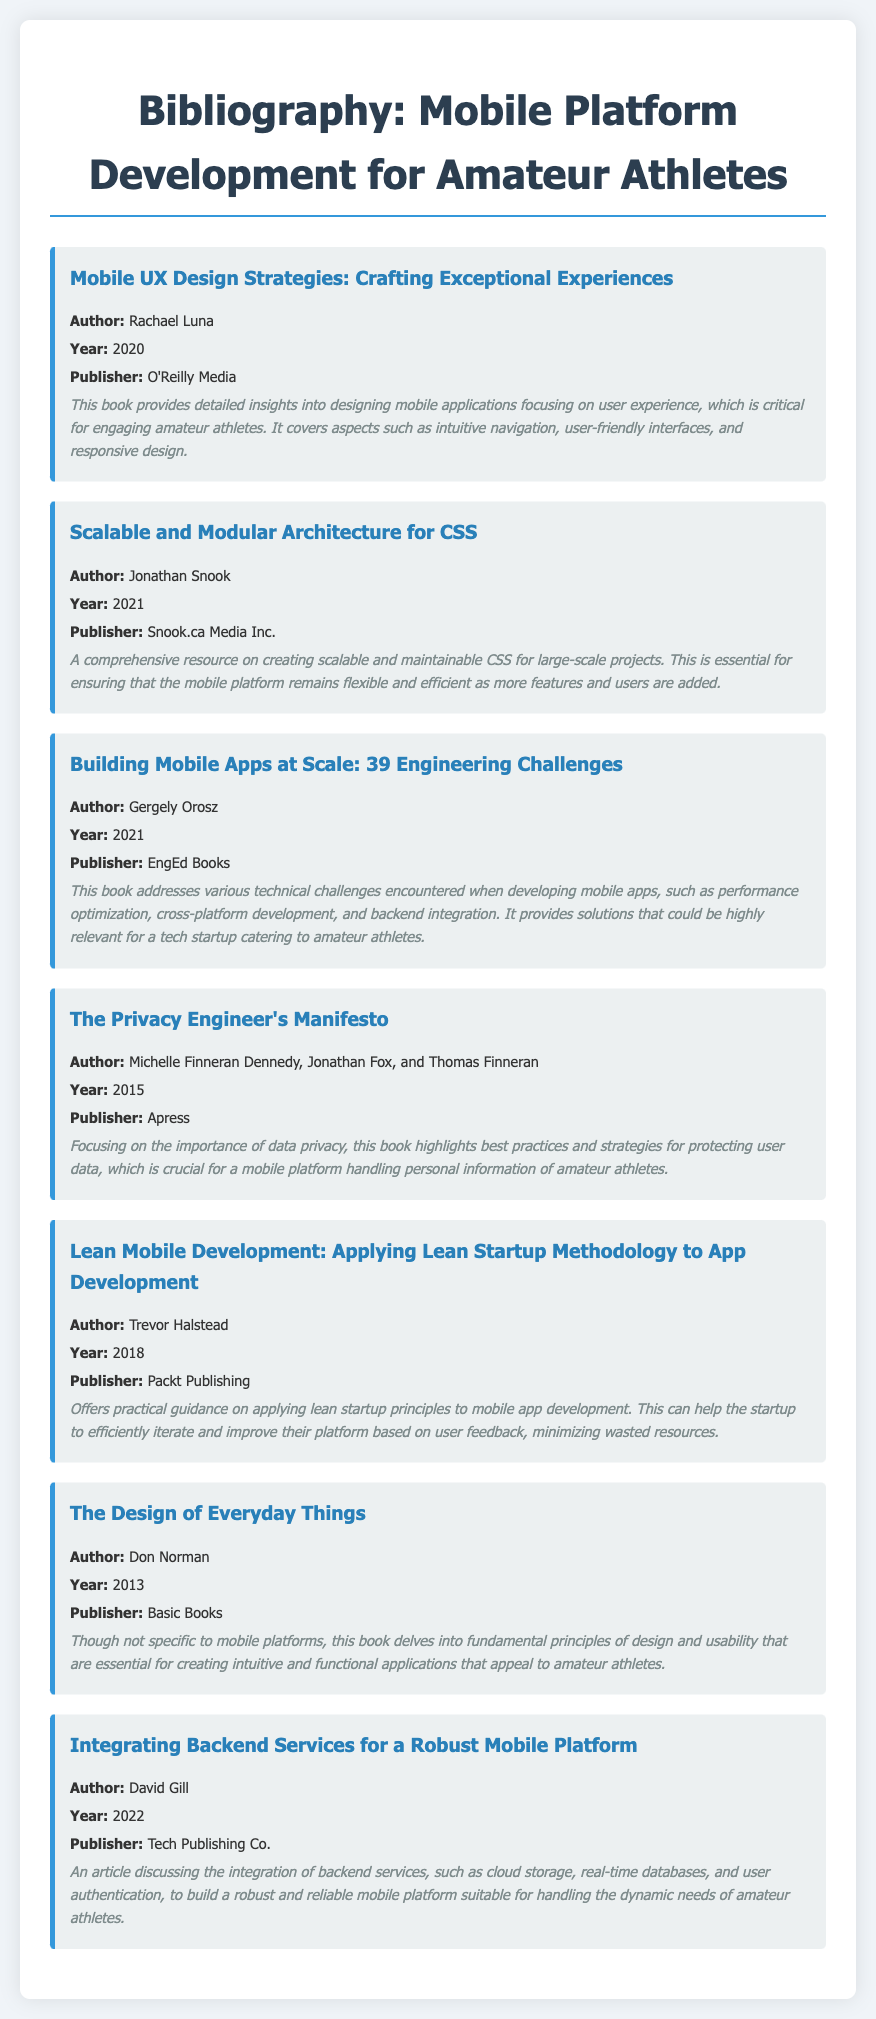what is the title of the first item? The first item is titled "Mobile UX Design Strategies: Crafting Exceptional Experiences."
Answer: Mobile UX Design Strategies: Crafting Exceptional Experiences who is the author of the book published in 2021? The book published in 2021 is "Scalable and Modular Architecture for CSS," and the author is Jonathan Snook.
Answer: Jonathan Snook what year was "Building Mobile Apps at Scale: 39 Engineering Challenges" published? The year of publication for "Building Mobile Apps at Scale: 39 Engineering Challenges" is 2021.
Answer: 2021 which publisher released "The Privacy Engineer's Manifesto"? "The Privacy Engineer's Manifesto" was published by Apress.
Answer: Apress what is a key focus of the book "Lean Mobile Development"? A key focus of "Lean Mobile Development" is applying lean startup principles to mobile app development.
Answer: applying lean startup principles which item discusses backend services integration? The item discussing backend services integration is "Integrating Backend Services for a Robust Mobile Platform."
Answer: Integrating Backend Services for a Robust Mobile Platform how many authors contributed to "The Privacy Engineer's Manifesto"? "The Privacy Engineer's Manifesto" has three authors.
Answer: three what common theme is addressed across several items in the bibliography? A common theme addressed is the design and user experience for mobile platforms.
Answer: design and user experience 